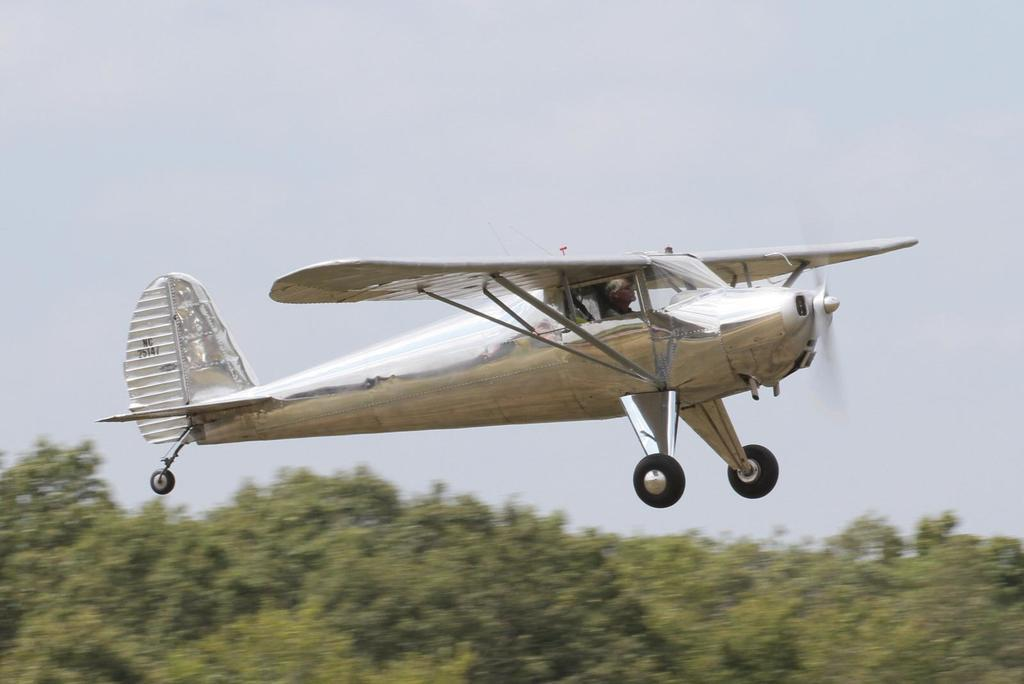What is the main subject of the image? The main subject of the image is an airplane. What is the airplane doing in the image? The airplane is flying in the air. Can you tell if there is anyone inside the airplane? Yes, there is a person inside the airplane. What can be seen at the bottom of the image? There are trees at the bottom of the image. What is visible at the top of the image? The sky is visible at the top of the image. How many jellyfish can be seen swimming in the airplane's engine in the image? There are no jellyfish present in the image, and they cannot swim in an airplane's engine. What type of lamp is hanging from the airplane's wing in the image? There is no lamp hanging from the airplane's wing in the image. 